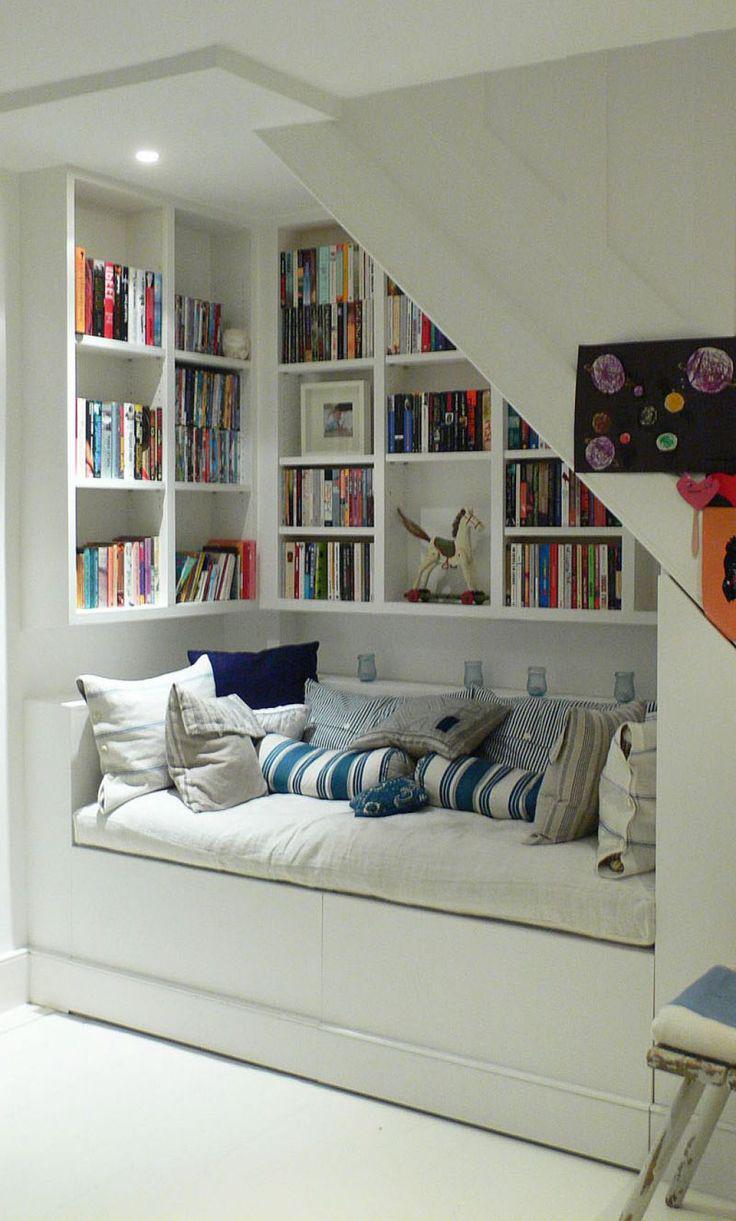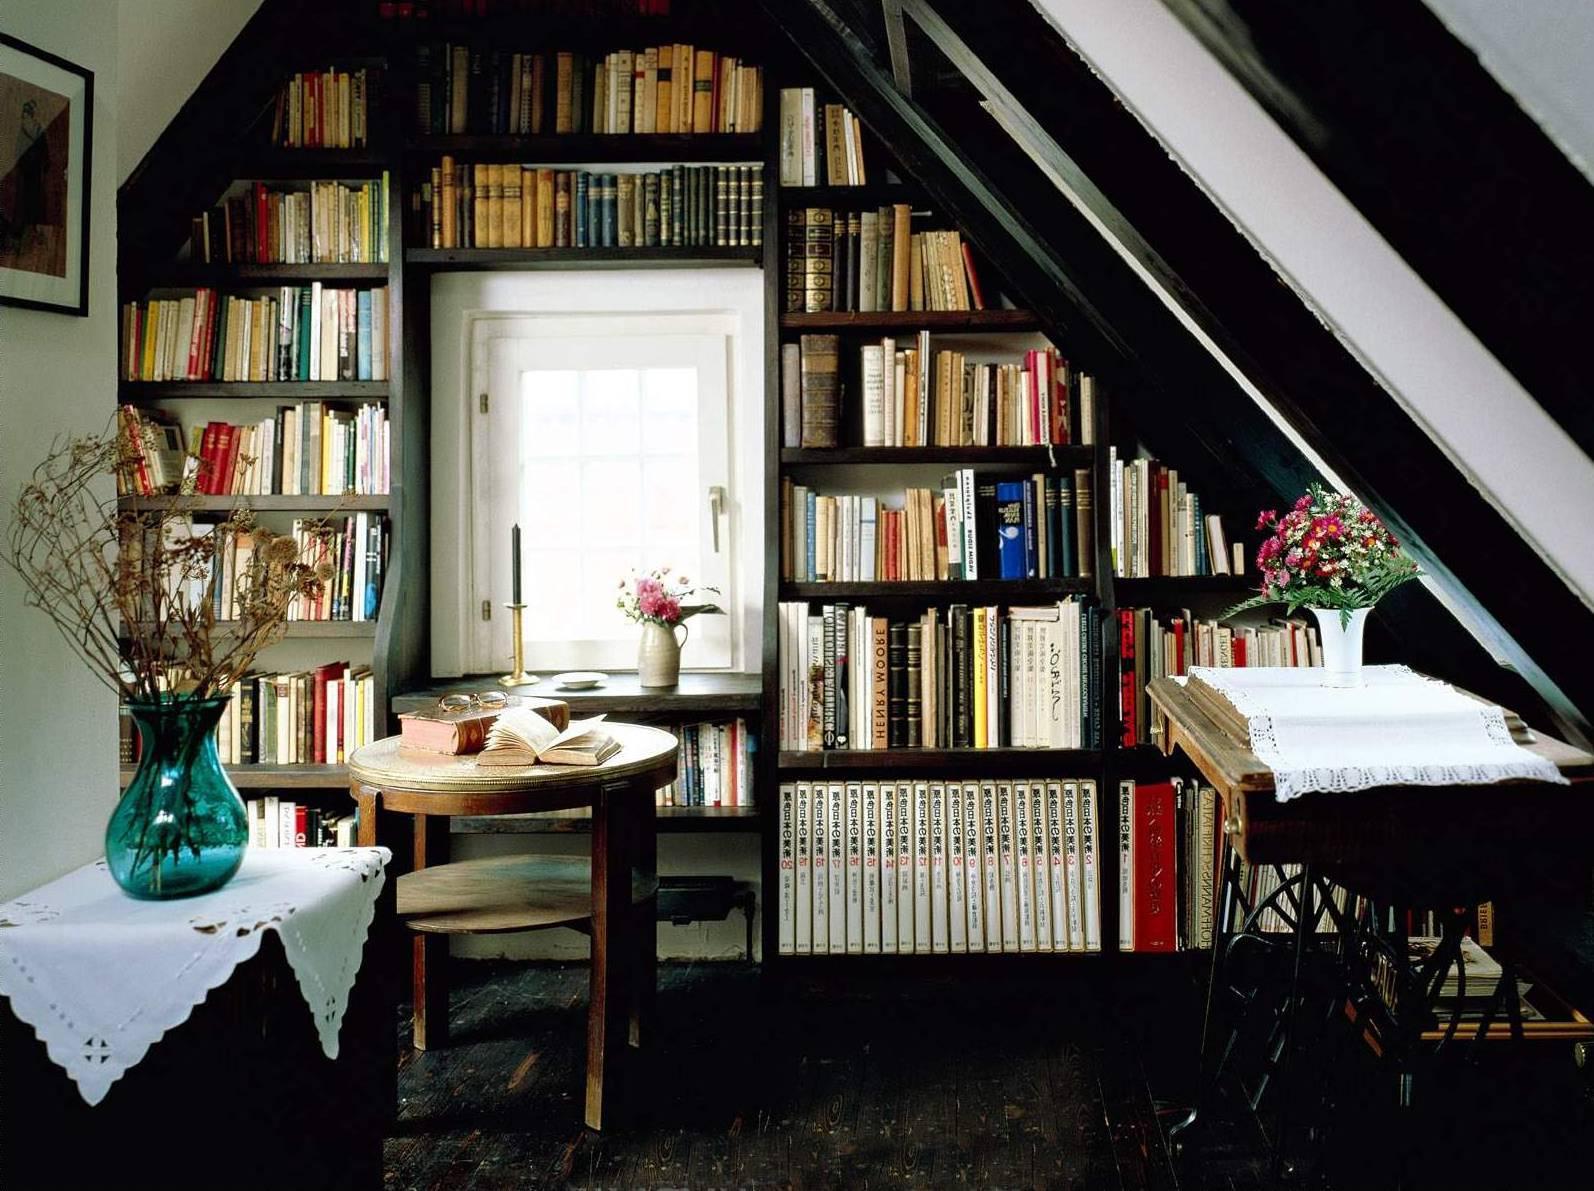The first image is the image on the left, the second image is the image on the right. For the images displayed, is the sentence "An image shows a square skylight in the peaked ceiling of a room with shelves along the wall." factually correct? Answer yes or no. No. The first image is the image on the left, the second image is the image on the right. Analyze the images presented: Is the assertion "In one image, a couch with throw pillows, a coffee table and at least one side chair form a seating area in front of a wall of bookshelves." valid? Answer yes or no. No. 